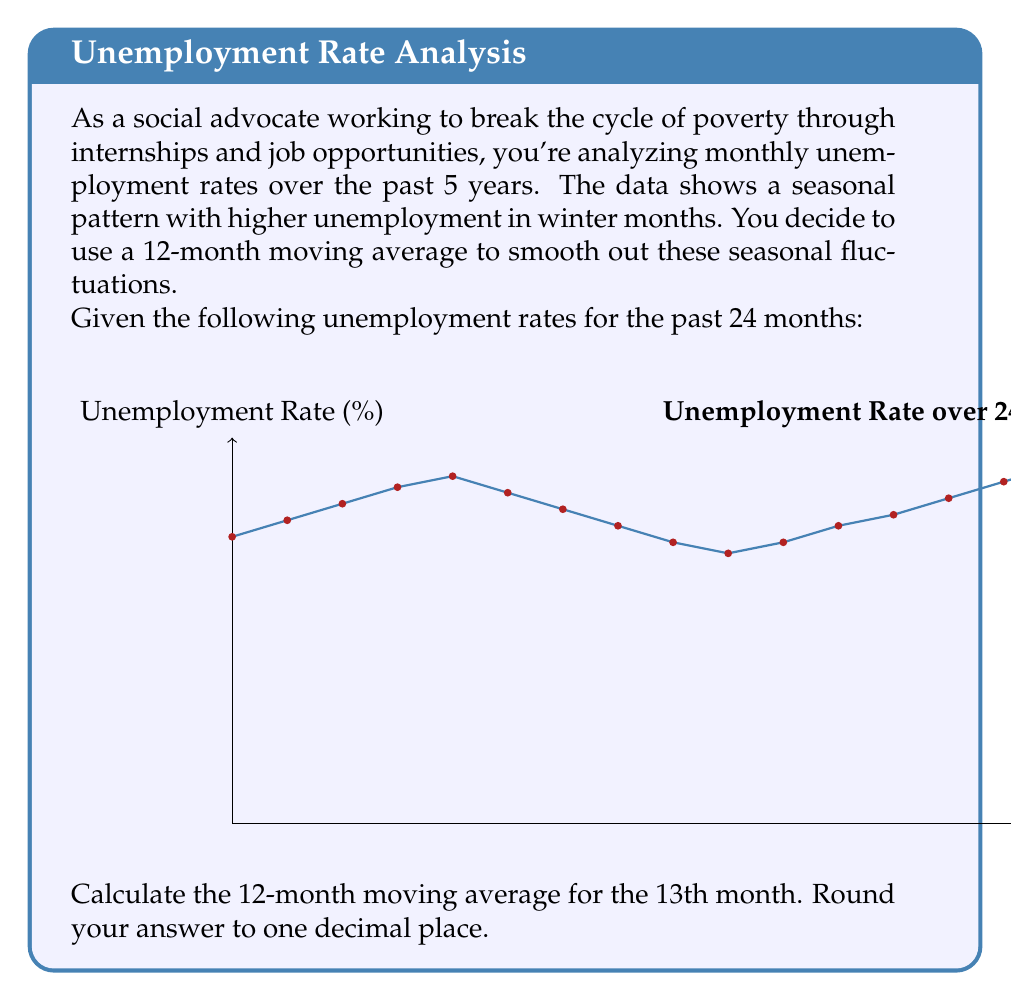Show me your answer to this math problem. To calculate the 12-month moving average for the 13th month, we need to follow these steps:

1) The 12-month moving average is calculated by taking the average of the unemployment rates for the current month and the previous 11 months.

2) For the 13th month, we need to consider the unemployment rates from month 2 to month 13 (12 months in total).

3) Let's sum up these 12 values:

   $5.5 + 5.8 + 6.1 + 6.3 + 6.0 + 5.7 + 5.4 + 5.1 + 4.9 + 5.1 + 5.4 + 5.6 = 67.9$

4) Now, we divide this sum by 12 to get the average:

   $\frac{67.9}{12} = 5.658333...$

5) Rounding to one decimal place:

   $5.658333... \approx 5.7$

This moving average helps smooth out the seasonal fluctuations, allowing us to identify longer-term trends in unemployment. As a social advocate, this information can help you determine when and where to focus your efforts in providing internships and job opportunities to effectively combat poverty.
Answer: 5.7% 